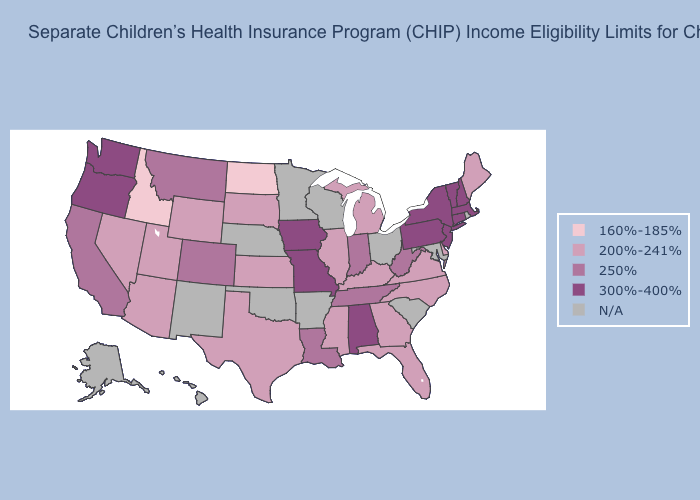Among the states that border Kentucky , which have the highest value?
Short answer required. Missouri. Which states have the highest value in the USA?
Be succinct. Alabama, Connecticut, Iowa, Massachusetts, Missouri, New Hampshire, New Jersey, New York, Oregon, Pennsylvania, Vermont, Washington. What is the value of Florida?
Keep it brief. 200%-241%. Name the states that have a value in the range 160%-185%?
Answer briefly. Idaho, North Dakota. Name the states that have a value in the range N/A?
Write a very short answer. Alaska, Arkansas, Hawaii, Maryland, Minnesota, Nebraska, New Mexico, Ohio, Oklahoma, Rhode Island, South Carolina, Wisconsin. Does Idaho have the lowest value in the USA?
Be succinct. Yes. What is the lowest value in the Northeast?
Answer briefly. 200%-241%. Does Nevada have the highest value in the West?
Quick response, please. No. What is the value of Ohio?
Write a very short answer. N/A. Does Utah have the lowest value in the USA?
Short answer required. No. Does Kentucky have the lowest value in the USA?
Short answer required. No. Which states have the lowest value in the South?
Keep it brief. Delaware, Florida, Georgia, Kentucky, Mississippi, North Carolina, Texas, Virginia. Among the states that border Georgia , does North Carolina have the highest value?
Short answer required. No. Which states have the lowest value in the Northeast?
Answer briefly. Maine. Name the states that have a value in the range 200%-241%?
Give a very brief answer. Arizona, Delaware, Florida, Georgia, Illinois, Kansas, Kentucky, Maine, Michigan, Mississippi, Nevada, North Carolina, South Dakota, Texas, Utah, Virginia, Wyoming. 